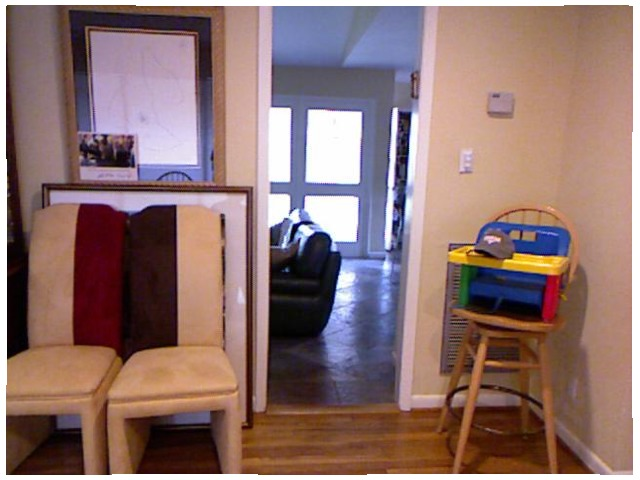<image>
Is the chair next to the couch? No. The chair is not positioned next to the couch. They are located in different areas of the scene. Where is the chair in relation to the chair? Is it to the right of the chair? Yes. From this viewpoint, the chair is positioned to the right side relative to the chair. Where is the chair in relation to the picture? Is it in the picture? No. The chair is not contained within the picture. These objects have a different spatial relationship. 